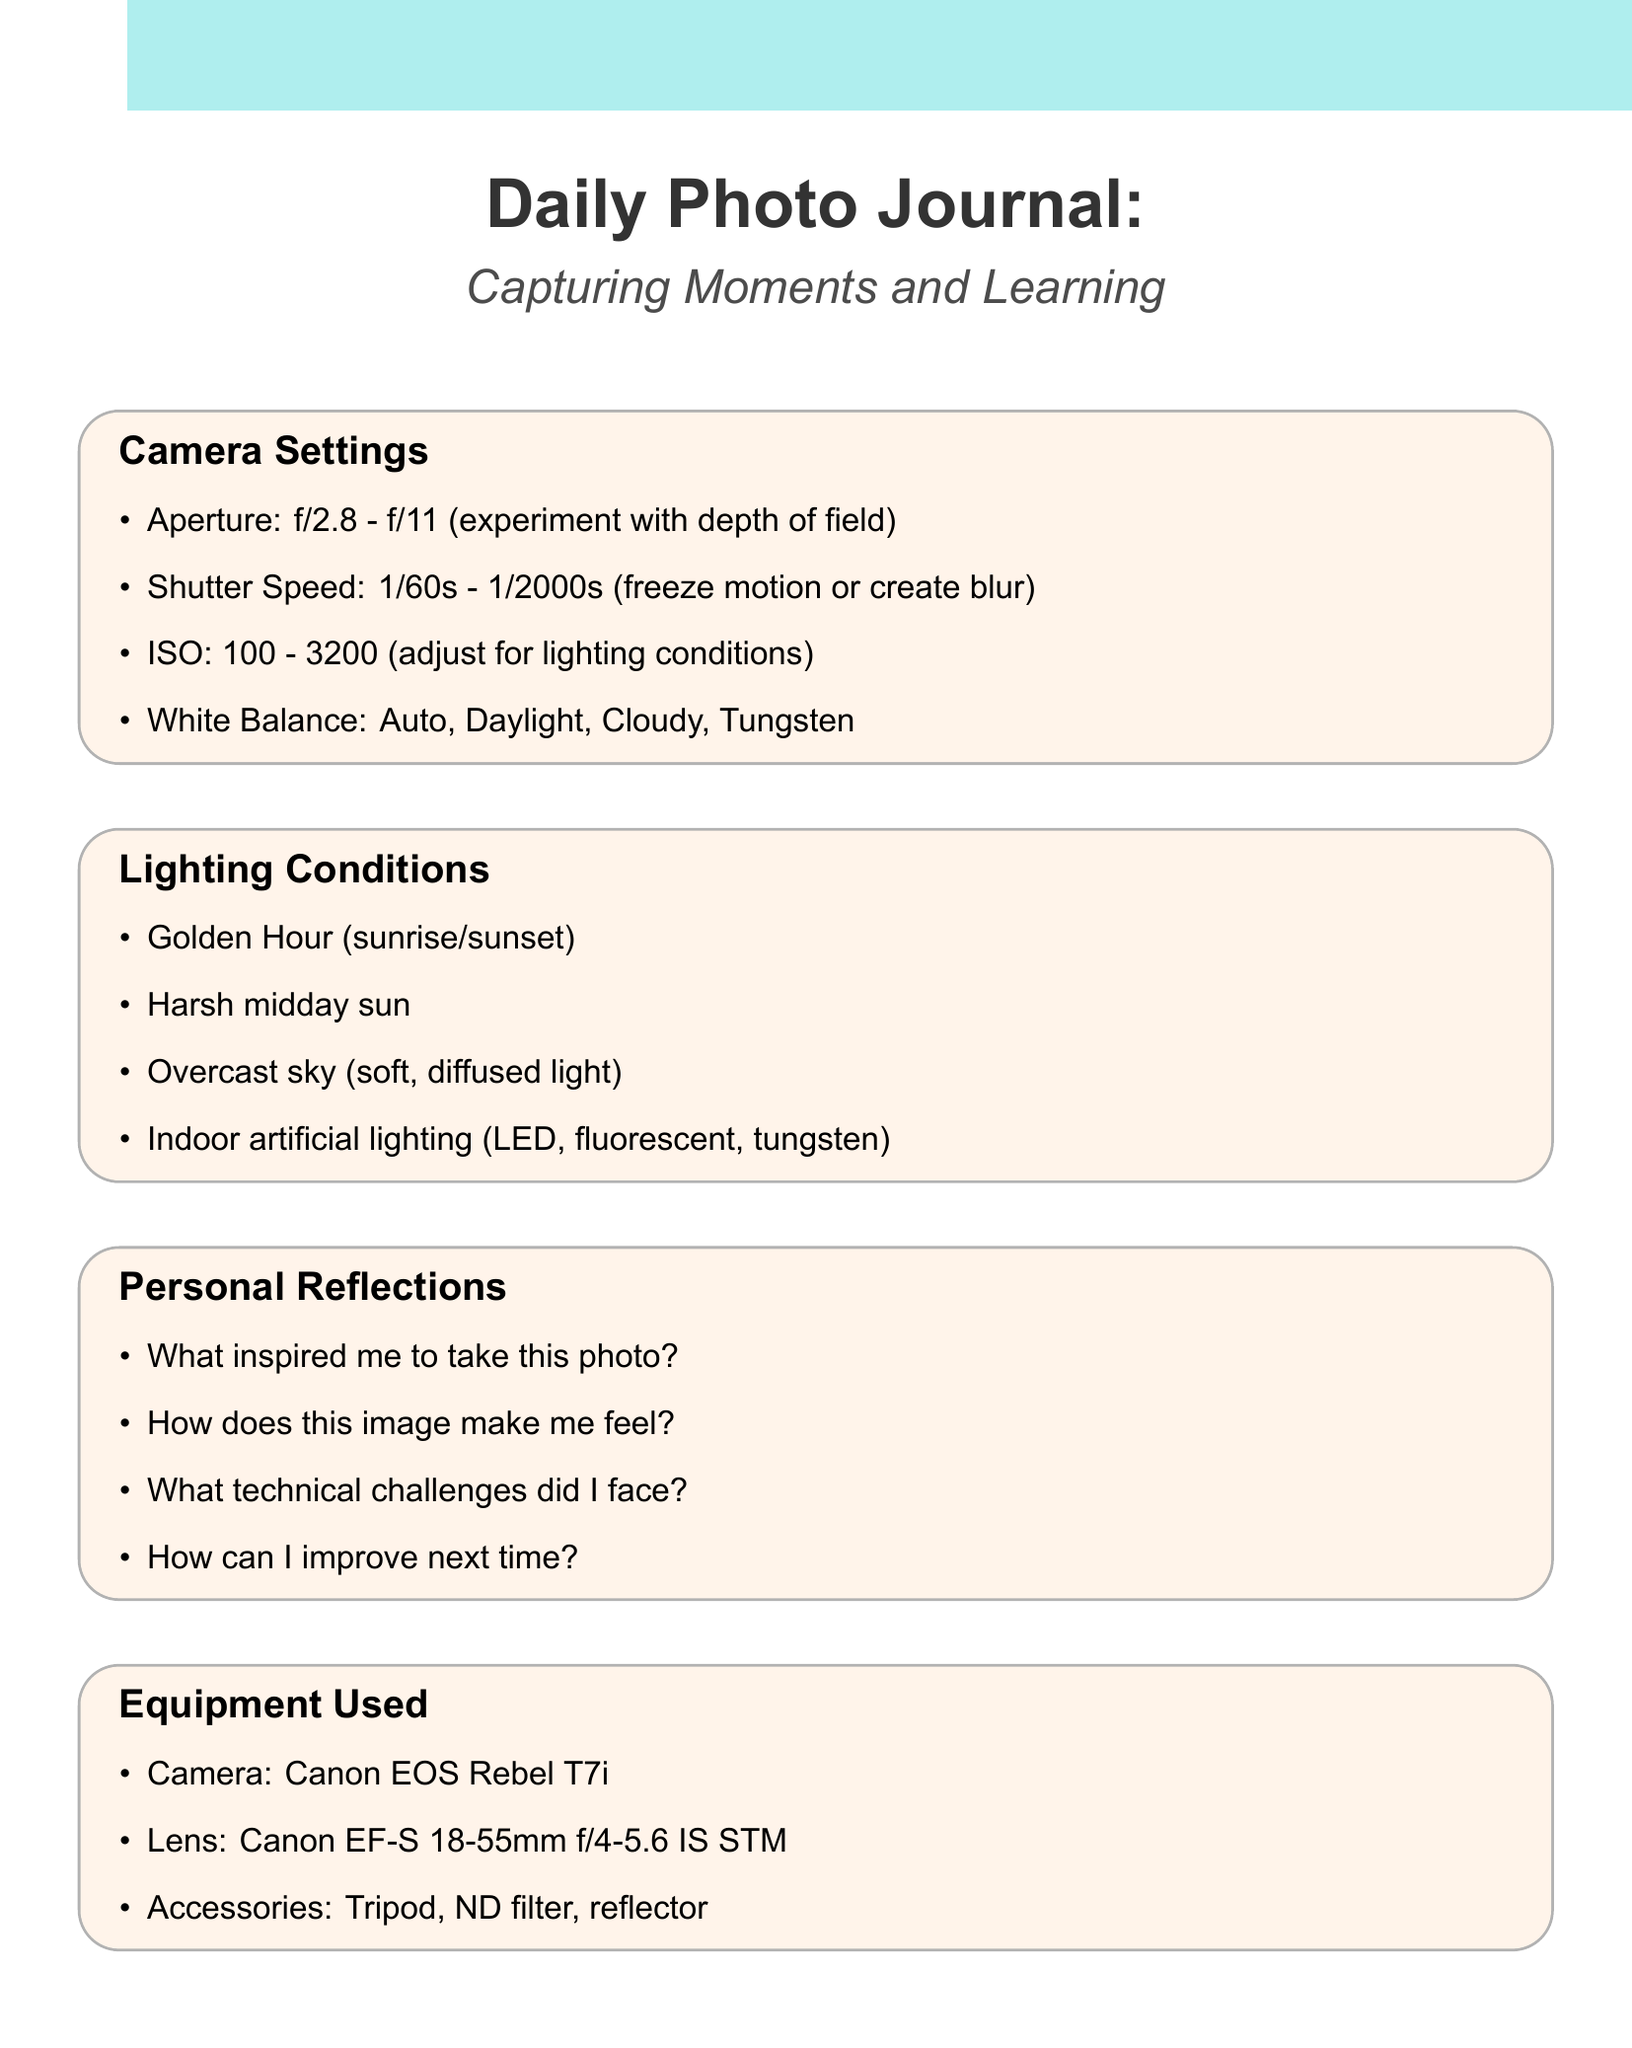What is the aperture range? The aperture range is mentioned under the Camera Settings section, specifically stating f/2.8 - f/11.
Answer: f/2.8 - f/11 What lighting condition is ideal during sunrise? The lighting condition called "Golden Hour" is ideal during sunrise, as noted in the Lighting Conditions section.
Answer: Golden Hour What software is used for post-processing? The software for post-processing is specified in the Post-Processing section. In this case, it is Adobe Lightroom Classic.
Answer: Adobe Lightroom Classic What is one of the personal reflection questions? The Personal Reflections section lists several questions, one being: "What inspired me to take this photo?"
Answer: What inspired me to take this photo? How fast can shutter speed be set? The shutter speed range is given in the Camera Settings, which is between 1/60s - 1/2000s.
Answer: 1/60s - 1/2000s What camera model is specified in the equipment used? The Equipment Used section mentions the camera model as Canon EOS Rebel T7i.
Answer: Canon EOS Rebel T7i Which lighting condition results in diffused light? The Lighting Conditions section mentions "Overcast sky" as a situation that results in soft, diffused light.
Answer: Overcast sky What is an effect mentioned in post-processing? In the Post-Processing section, one of the effects listed is "Black and white conversion."
Answer: Black and white conversion How can one improve next time according to the reflections? The Personal Reflections section encourages an evaluation with the question "How can I improve next time?"
Answer: How can I improve next time? 